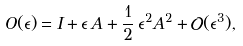<formula> <loc_0><loc_0><loc_500><loc_500>O ( \epsilon ) = I + \epsilon \, A + \frac { 1 } { 2 } \, \epsilon ^ { 2 } A ^ { 2 } + { \mathcal { O } } ( \epsilon ^ { 3 } ) ,</formula> 